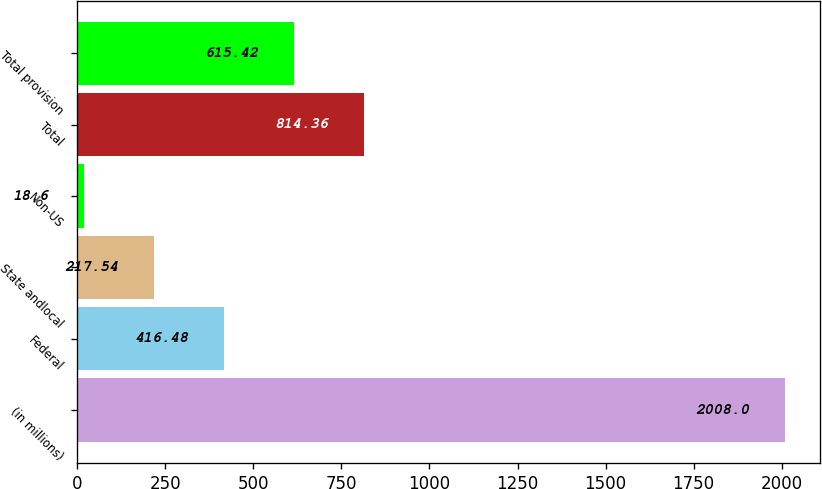Convert chart to OTSL. <chart><loc_0><loc_0><loc_500><loc_500><bar_chart><fcel>(in millions)<fcel>Federal<fcel>State andlocal<fcel>Non-US<fcel>Total<fcel>Total provision<nl><fcel>2008<fcel>416.48<fcel>217.54<fcel>18.6<fcel>814.36<fcel>615.42<nl></chart> 